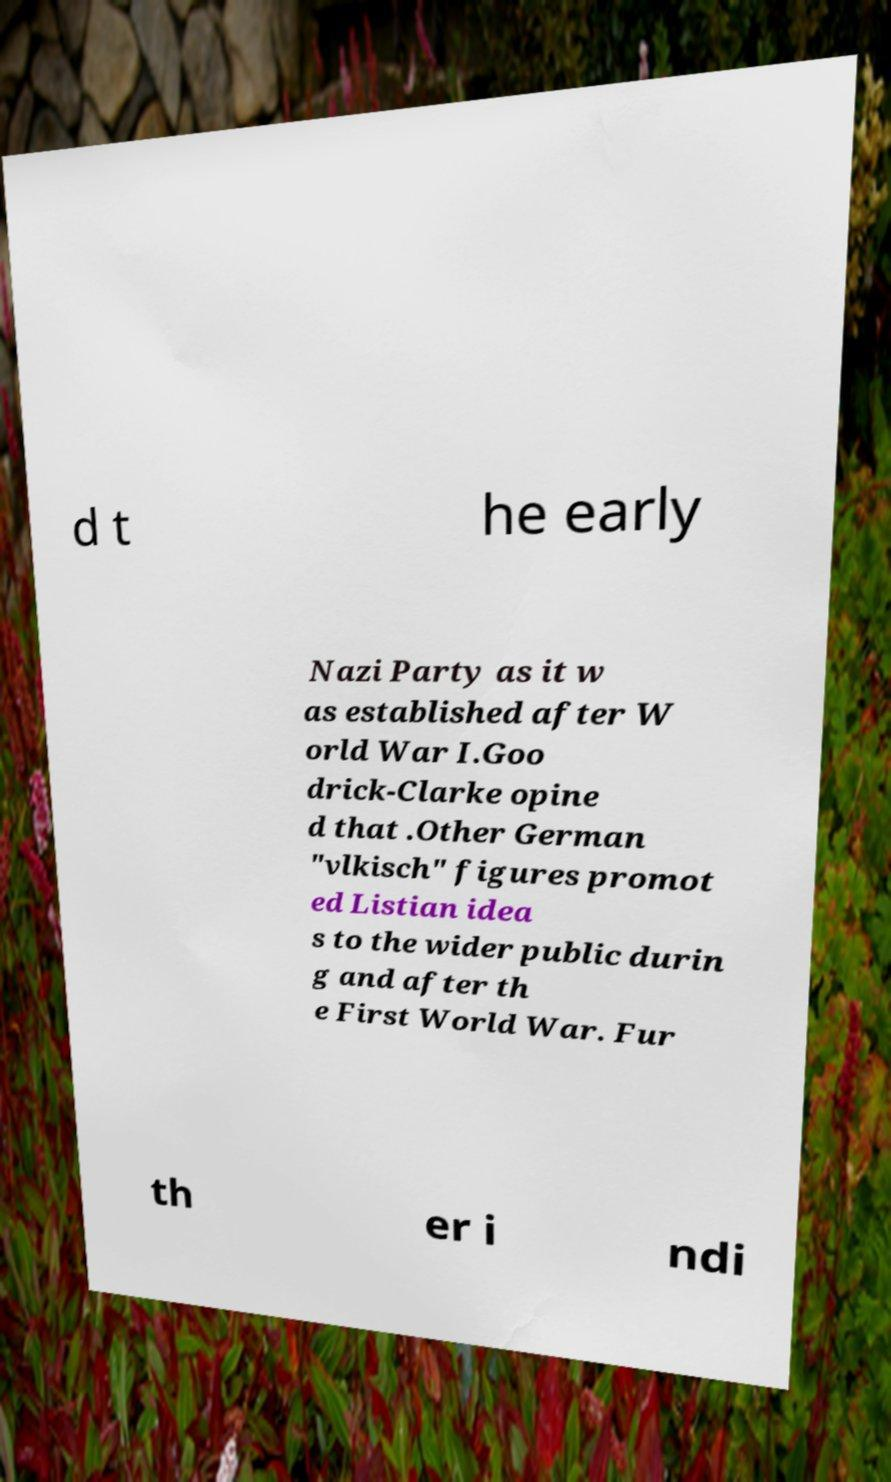Could you extract and type out the text from this image? d t he early Nazi Party as it w as established after W orld War I.Goo drick-Clarke opine d that .Other German "vlkisch" figures promot ed Listian idea s to the wider public durin g and after th e First World War. Fur th er i ndi 